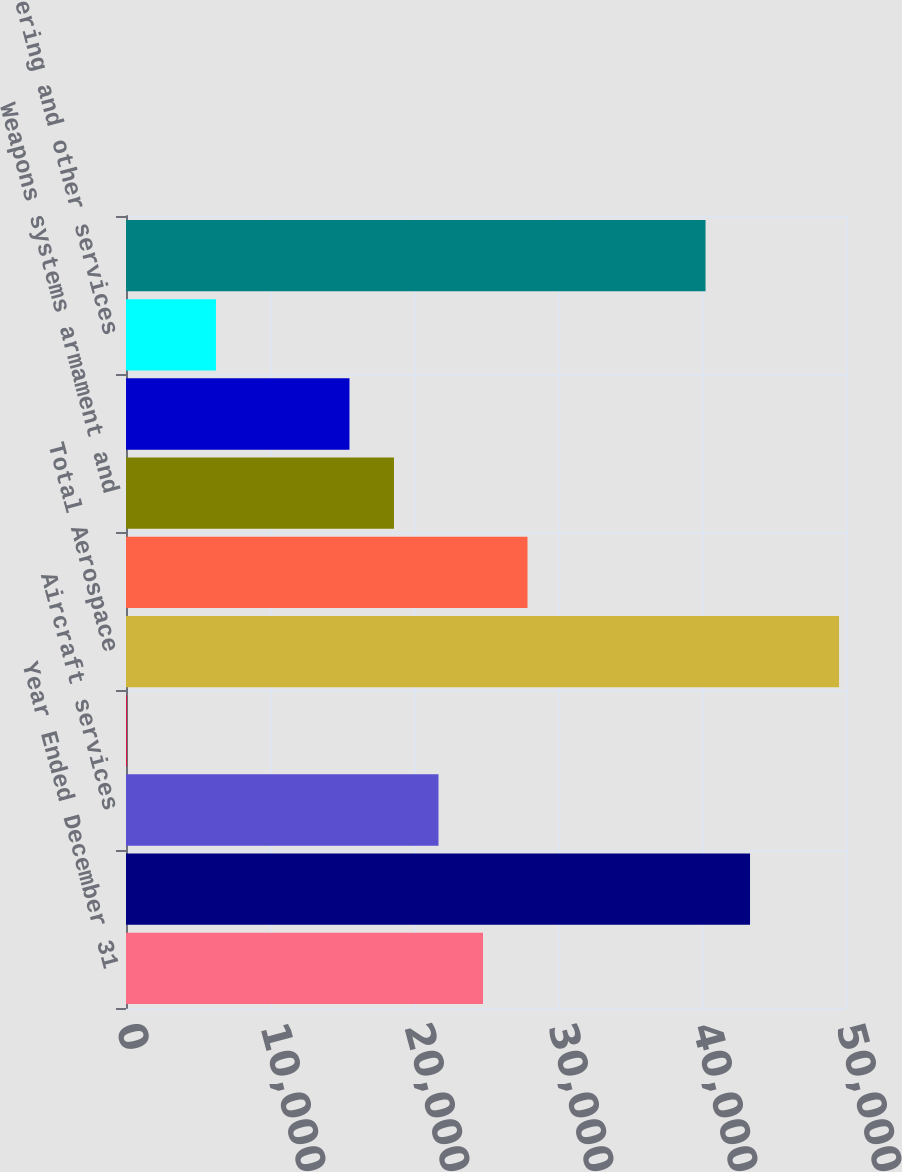Convert chart. <chart><loc_0><loc_0><loc_500><loc_500><bar_chart><fcel>Year Ended December 31<fcel>Aircraft manufacturing<fcel>Aircraft services<fcel>Pre-owned aircraft<fcel>Total Aerospace<fcel>Wheeled combat and tactical<fcel>Weapons systems armament and<fcel>Tanks and tracked vehicles<fcel>Engineering and other services<fcel>Total Combat Systems<nl><fcel>24791.6<fcel>43335.8<fcel>21700.9<fcel>66<fcel>49517.2<fcel>27882.3<fcel>18610.2<fcel>15519.5<fcel>6247.4<fcel>40245.1<nl></chart> 